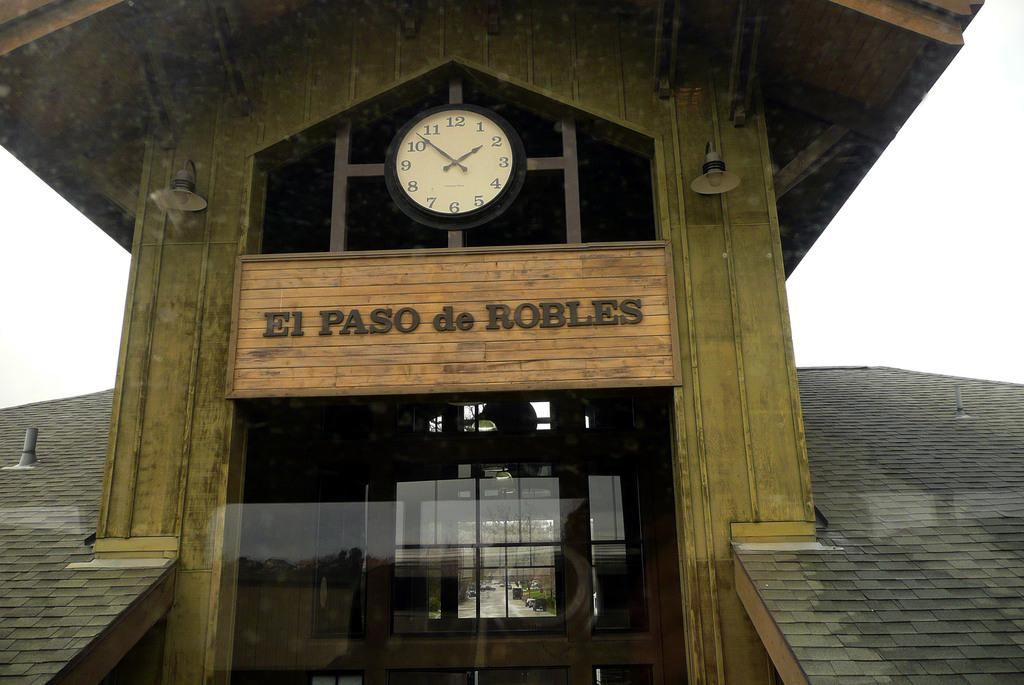<image>
Offer a succinct explanation of the picture presented. A sign for El Paso de Robles is underneath a clock. 